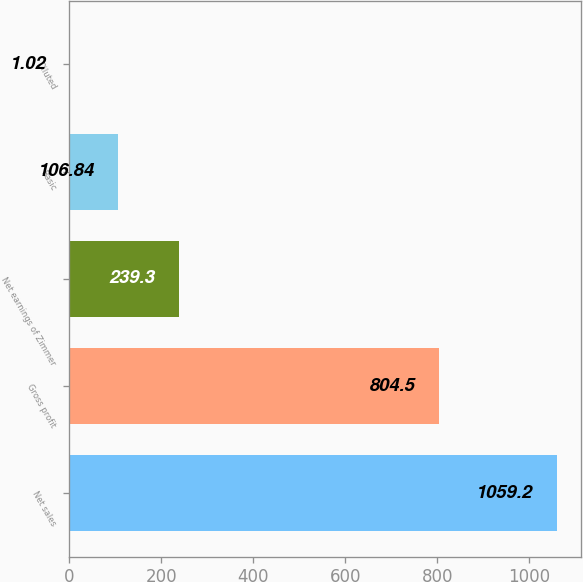<chart> <loc_0><loc_0><loc_500><loc_500><bar_chart><fcel>Net sales<fcel>Gross profit<fcel>Net earnings of Zimmer<fcel>Basic<fcel>Diluted<nl><fcel>1059.2<fcel>804.5<fcel>239.3<fcel>106.84<fcel>1.02<nl></chart> 